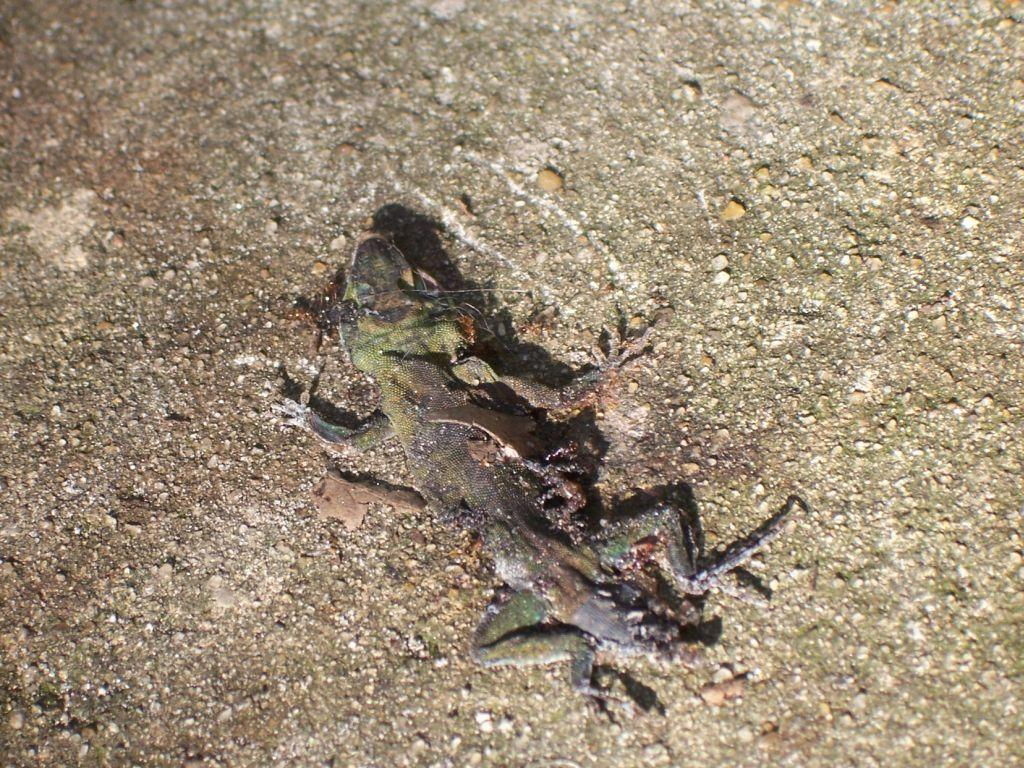What type of animal is present in the image? There is a lizard in the image. Where is the lizard located in the image? The lizard is on a surface. What type of polish is the lizard using to shine its scales in the image? There is no polish or indication of the lizard using any polish in the image. 